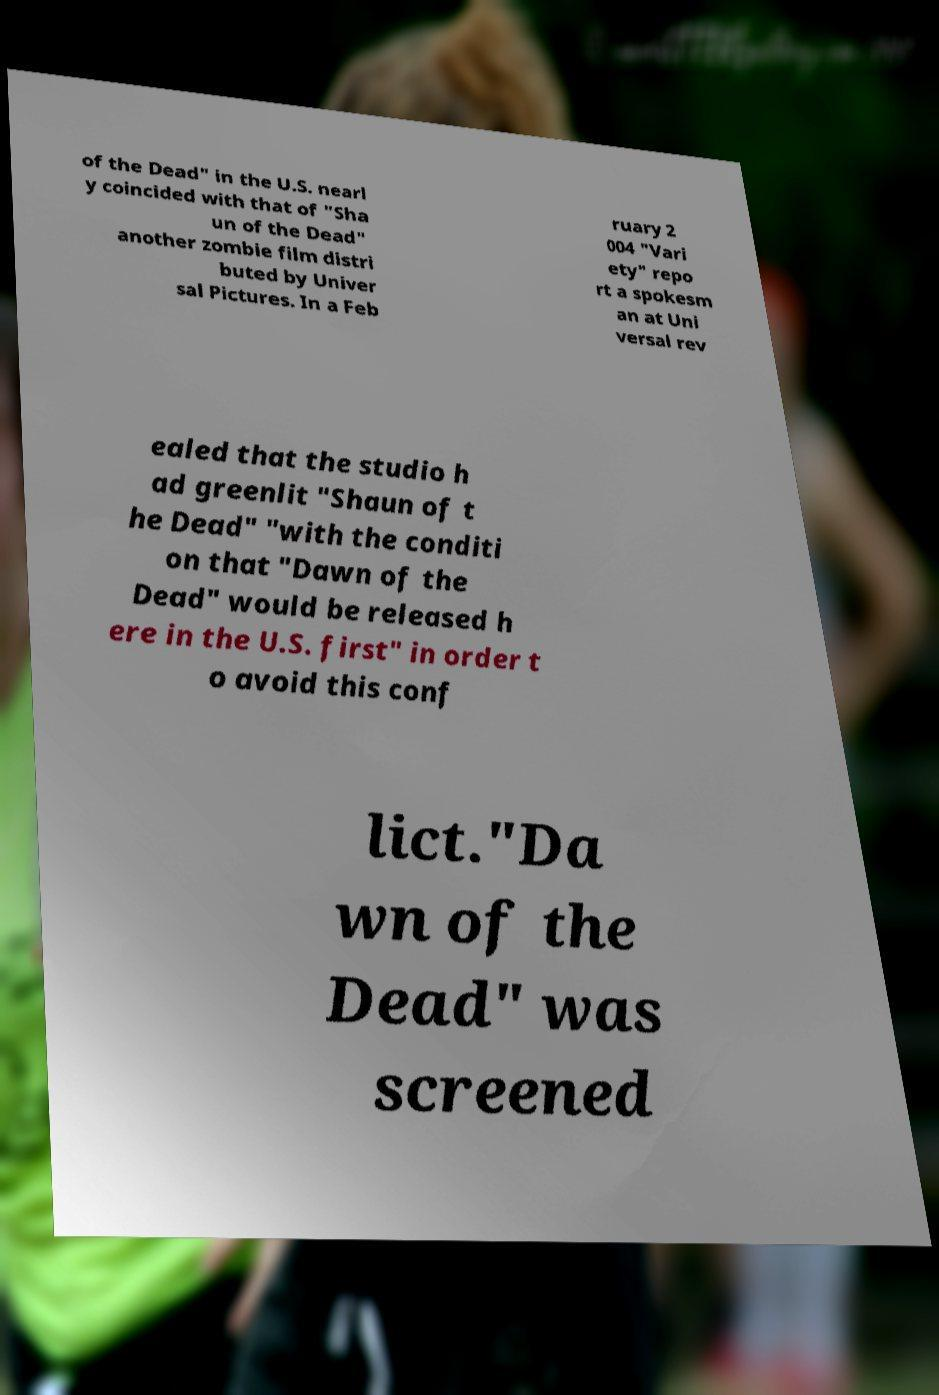There's text embedded in this image that I need extracted. Can you transcribe it verbatim? of the Dead" in the U.S. nearl y coincided with that of "Sha un of the Dead" another zombie film distri buted by Univer sal Pictures. In a Feb ruary 2 004 "Vari ety" repo rt a spokesm an at Uni versal rev ealed that the studio h ad greenlit "Shaun of t he Dead" "with the conditi on that "Dawn of the Dead" would be released h ere in the U.S. first" in order t o avoid this conf lict."Da wn of the Dead" was screened 